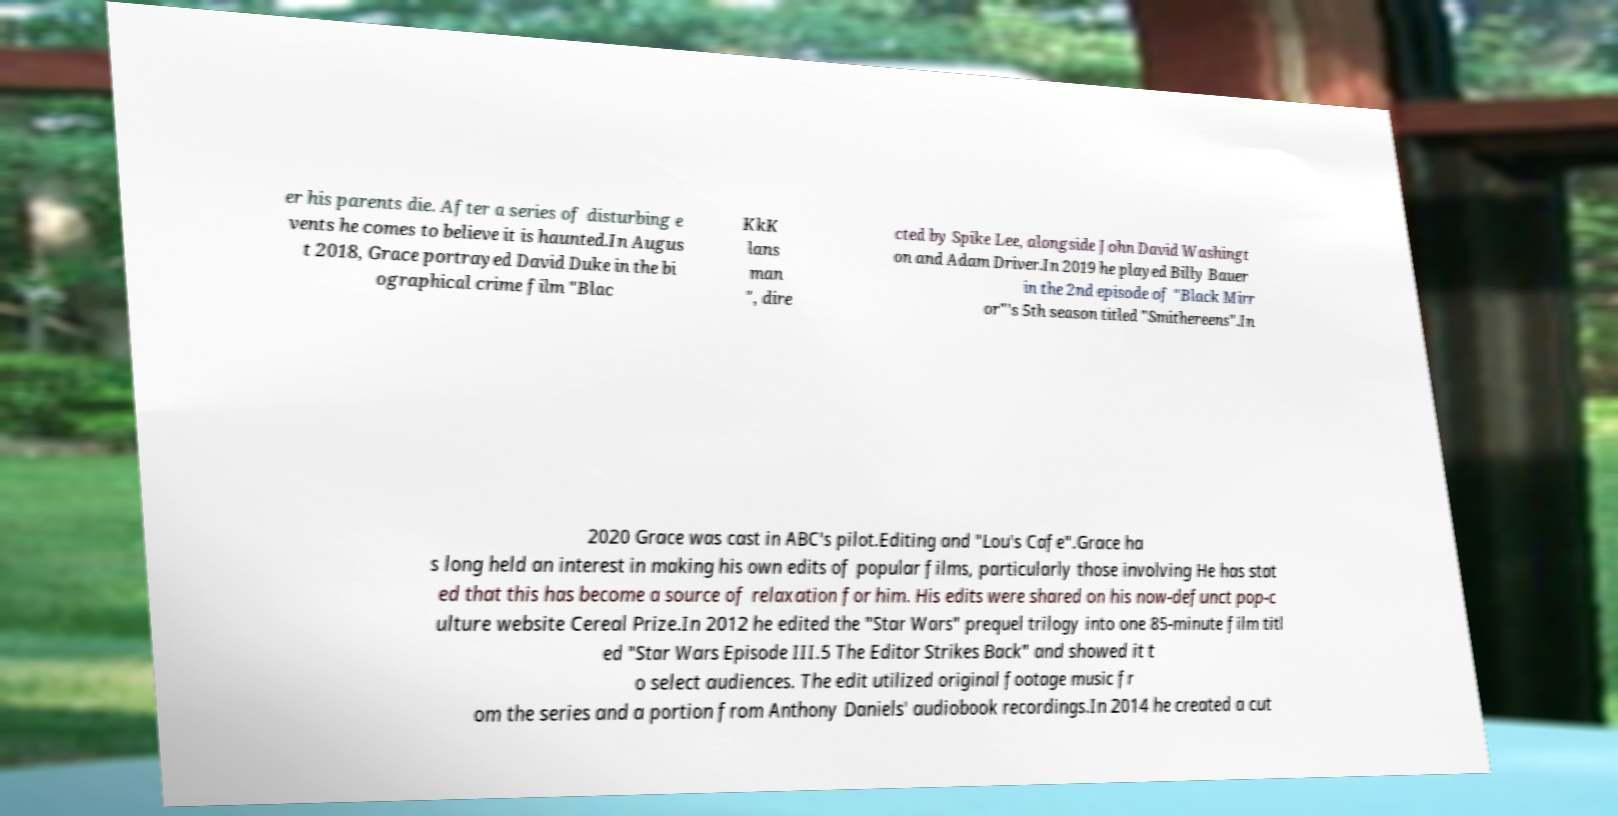Please identify and transcribe the text found in this image. er his parents die. After a series of disturbing e vents he comes to believe it is haunted.In Augus t 2018, Grace portrayed David Duke in the bi ographical crime film "Blac KkK lans man ", dire cted by Spike Lee, alongside John David Washingt on and Adam Driver.In 2019 he played Billy Bauer in the 2nd episode of "Black Mirr or"’s 5th season titled "Smithereens".In 2020 Grace was cast in ABC's pilot.Editing and "Lou's Cafe".Grace ha s long held an interest in making his own edits of popular films, particularly those involving He has stat ed that this has become a source of relaxation for him. His edits were shared on his now-defunct pop-c ulture website Cereal Prize.In 2012 he edited the "Star Wars" prequel trilogy into one 85-minute film titl ed "Star Wars Episode III.5 The Editor Strikes Back" and showed it t o select audiences. The edit utilized original footage music fr om the series and a portion from Anthony Daniels' audiobook recordings.In 2014 he created a cut 